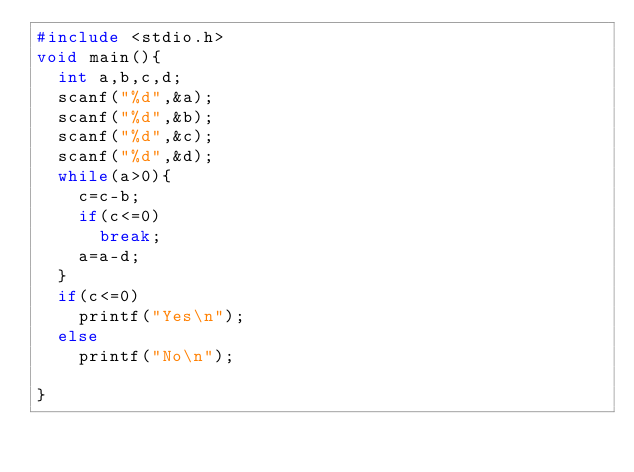Convert code to text. <code><loc_0><loc_0><loc_500><loc_500><_C_>#include <stdio.h>
void main(){
  int a,b,c,d;
  scanf("%d",&a);
  scanf("%d",&b);
  scanf("%d",&c);
  scanf("%d",&d);
  while(a>0){
    c=c-b;
    if(c<=0)
      break;
    a=a-d;
  }
  if(c<=0)
    printf("Yes\n");
  else
    printf("No\n");
  
}</code> 